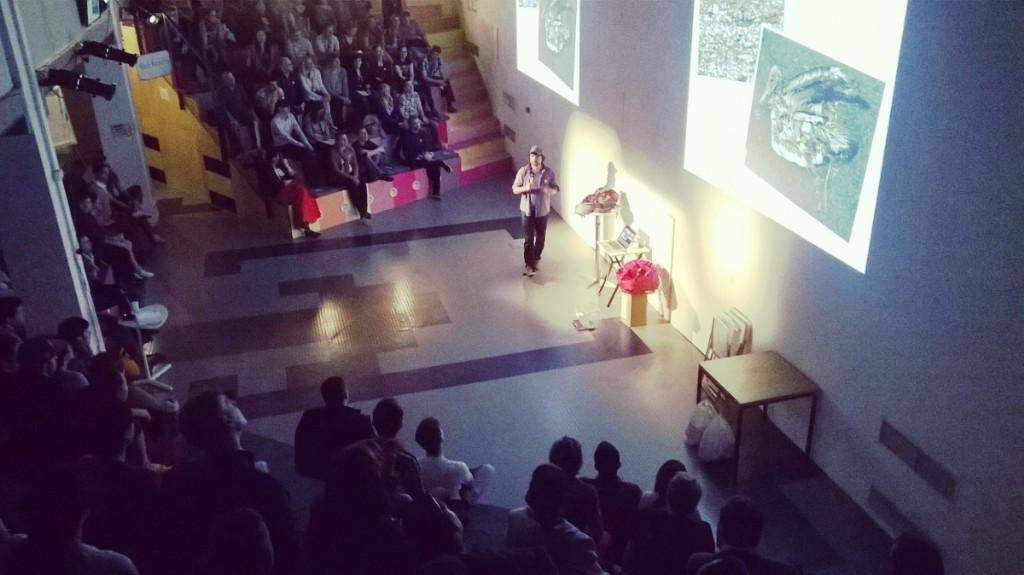How would you summarize this image in a sentence or two? In the center of the image we can see a person standing on the floor, a laptop and some bags are placed on tables. On the right side of the image we can see screen, chairs, table and covers placed on the ground. In the background, we can see group of audience, some lights and pillars. 